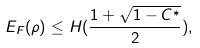Convert formula to latex. <formula><loc_0><loc_0><loc_500><loc_500>E _ { F } ( \rho ) \leq H ( \frac { 1 + \sqrt { 1 - C ^ { * } } } { 2 } ) ,</formula> 